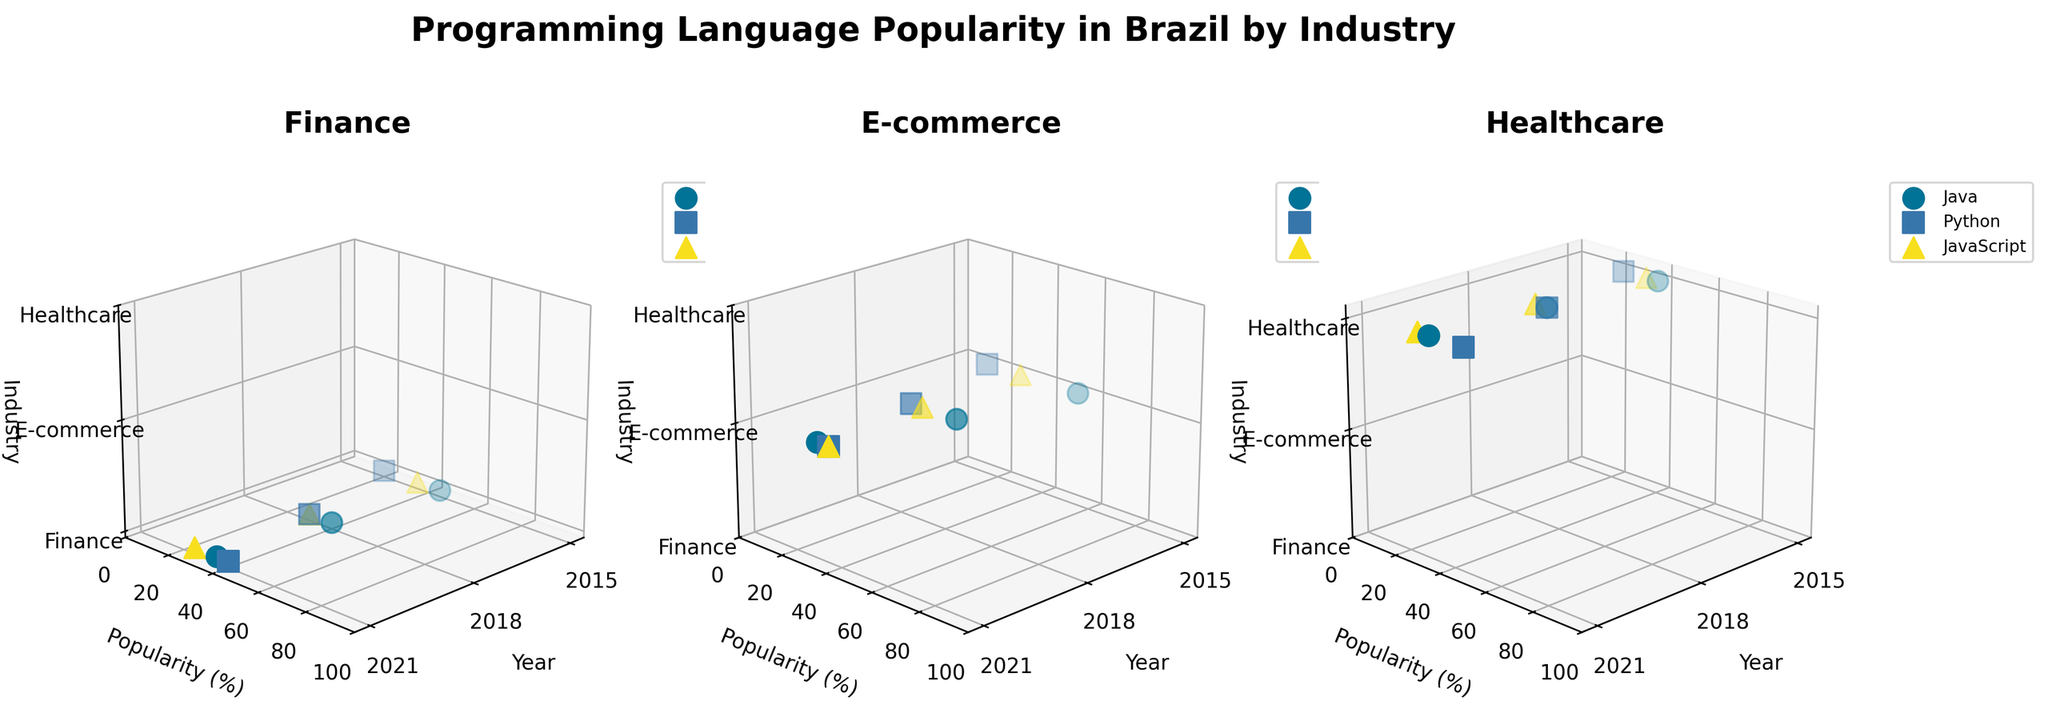Which industry has the highest popularity rate for JavaScript in 2021? To find this, look at the 2021 data points for JavaScript across all three subplots. Finance shows 25%, E-commerce shows 35%, and Healthcare shows 25%. Thus, E-commerce has the highest popularity for JavaScript in 2021.
Answer: E-commerce How did Python's popularity in Healthcare change from 2015 to 2021? Analyze the data points for Python in the Healthcare subplot. In 2015, the popularity is 25%, in 2018 it is 35%, and in 2021 it is 45%. So, it increased from 25% to 45% over this period.
Answer: Increased Which year shows a higher popularity for Java in the Finance industry, 2015 or 2021? Compare the popularity of Java in the Finance sector between 2015 and 2021. In 2015, it is 45%. In 2021, it is 35%. Therefore, 2015 is higher.
Answer: 2015 What is the trend in Java popularity in the E-commerce industry from 2015 to 2021? Observe the Java data points in the E-commerce subplot. The popularity is 55% in 2015, 45% in 2018, and 30% in 2021. It shows a decreasing trend.
Answer: Decreasing Compare Python's popularity in Finance and Healthcare in 2021. Which one is more popular? Look at the 2021 data points for Python in both Finance and Healthcare subplots. Finance shows 40%, and Healthcare shows 45%. Therefore, Python is more popular in Healthcare.
Answer: Healthcare In which year was JavaScript's popularity equal in Finance and E-commerce? Find the year where the data points for JavaScript in both Finance and E-commerce are equal. In 2018, JavaScript shows 30% popularity in both Finance and E-commerce.
Answer: 2018 Which industry had the lowest popularity for Python in 2015? In 2015, check the popularity data points of Python across the three industry subplots. Finance has 20%, E-commerce has 15%, and Healthcare has 25%. E-commerce had the lowest popularity.
Answer: E-commerce What is the change in JavaScript's popularity in the Finance industry from 2015 to 2021? Observe the JavaScript data points in the Finance subplot. In 2015, it is 35%, in 2018 it is 30%, and in 2021 it is 25%. Hence, it decreased from 35% to 25%.
Answer: Decreased 